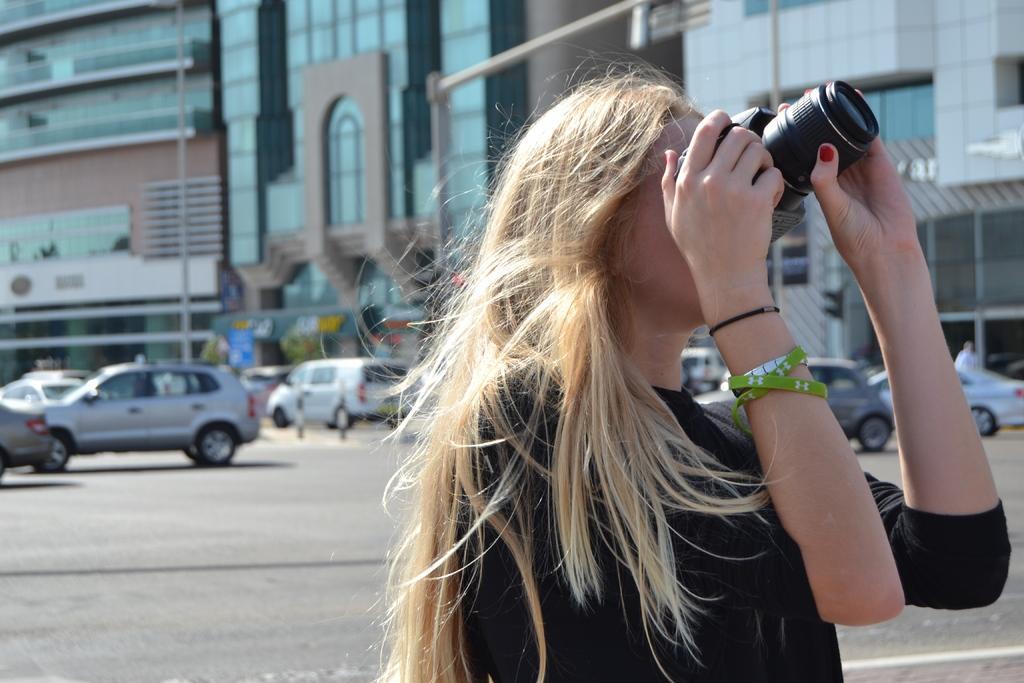Describe this image in one or two sentences. There is a woman on the right side holding a camera in her hand and she is capturing a photo. In the background we can see a few cars which are parked in a parking space and a building. 